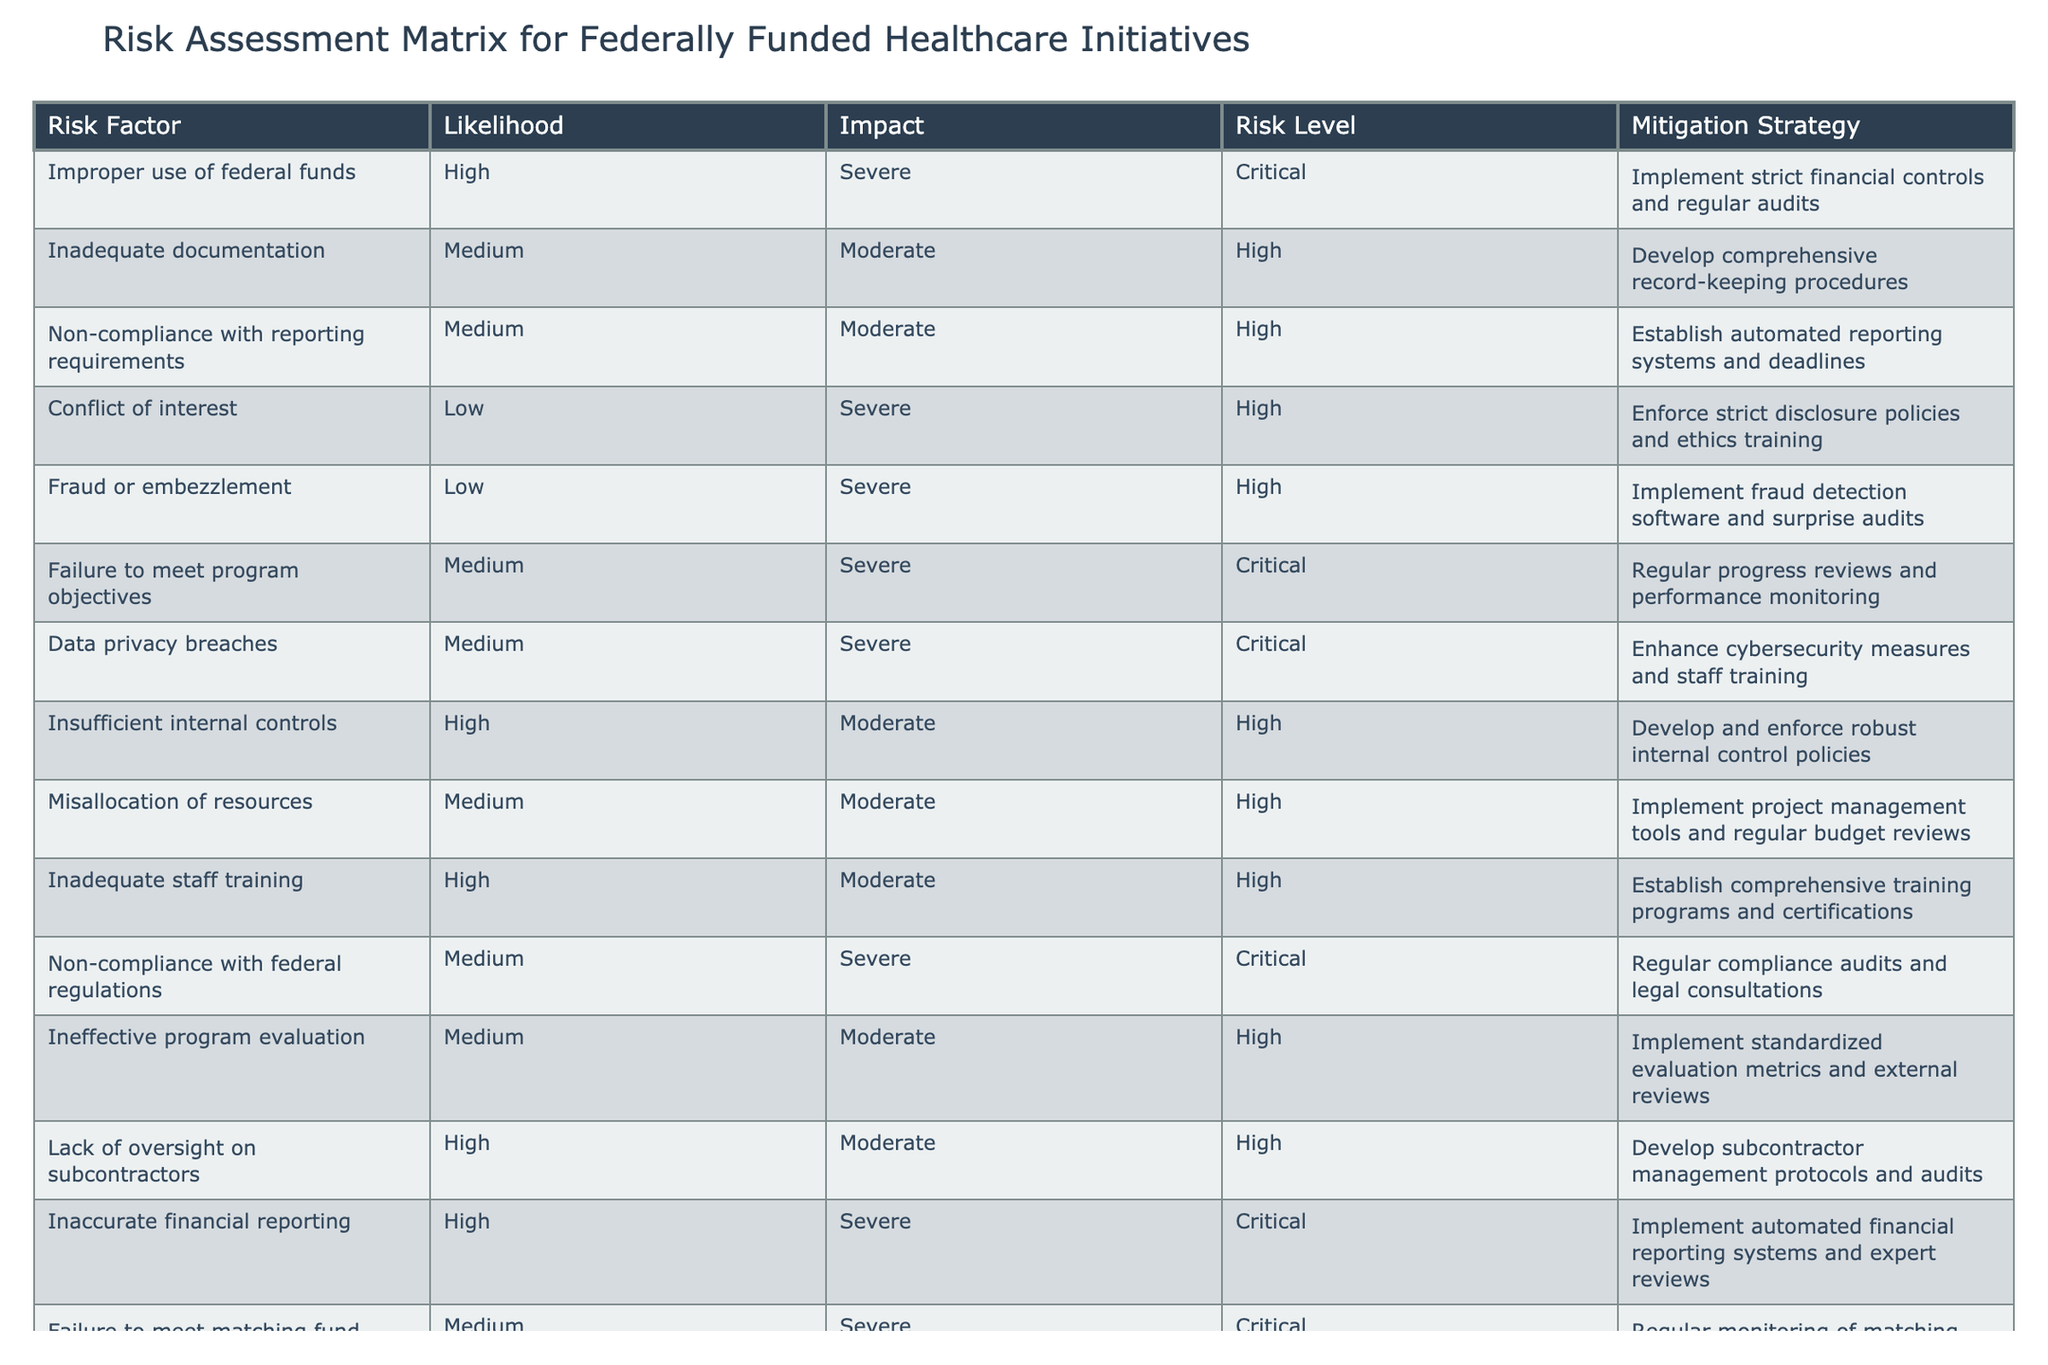What is the risk level associated with "Fraud or embezzlement"? The risk level is obtained from the table by locating the row for "Fraud or embezzlement" and checking the corresponding value in the "Risk Level" column, which is High.
Answer: High What is the mitigation strategy for "Inadequate documentation"? The mitigation strategy can be found by finding the row for "Inadequate documentation" and looking at the "Mitigation Strategy" column, which states to develop comprehensive record-keeping procedures.
Answer: Develop comprehensive record-keeping procedures Is "Conflict of interest" categorized as a Critical risk level? To answer this, we check the "Risk Level" for "Conflict of interest." Since it is classified as High, the answer is No.
Answer: No How many risk factors are classified under "High" risk level? We need to count the number of occurrences in the "Risk Level" column where the value is "High." The table contains five instances of "High" risk factors.
Answer: 5 What is the average likelihood of the risk factors that have a "Critical" risk level? To calculate this, identify the risk factors with a "Critical" risk level and extract their "Likelihood" values. The corresponding likelihood levels are High (2), Medium (2), and so on. Convert these categorizations into numerical values (High=3, Medium=2, Low=1), sum them up (3 + 2 + 2 = 7) and divide by the count (3). The average is approximately 2.33.
Answer: 2.33 What is the risk level of "Failure to meet matching fund requirements"? Checking the row for "Failure to meet matching fund requirements," we find that its risk level is Critical.
Answer: Critical Are there any risk factors with a Low likelihood that have a Critical risk level? Look at the "Risk Level" for all factors with "Low" likelihood. Since there are no factors meeting these criteria, the answer is No.
Answer: No How many mitigation strategies are focused on training? Reviewing the "Mitigation Strategy" column, we see that "Inadequate staff training" and "Data privacy breaches" implement training-related strategies, resulting in a total of two focused strategies.
Answer: 2 Which risk factor has the highest likelihood? Look at the "Likelihood" column, where "Improper use of federal funds" is listed as High, and verify if any other factors have a higher classification. As High is the maximum value, this confirms that it is the highest.
Answer: Improper use of federal funds 